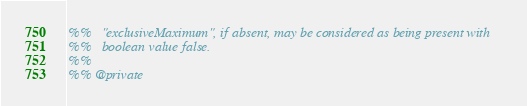<code> <loc_0><loc_0><loc_500><loc_500><_Erlang_>%%   "exclusiveMaximum", if absent, may be considered as being present with
%%   boolean value false.
%%
%% @private</code> 